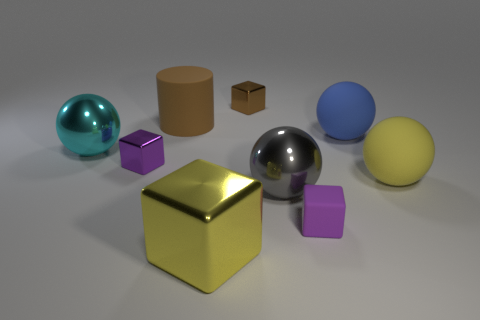There is a sphere that is the same color as the big shiny cube; what size is it?
Provide a succinct answer. Large. What number of other objects are there of the same shape as the blue rubber thing?
Ensure brevity in your answer.  3. Is the shape of the yellow thing that is right of the big shiny cube the same as  the cyan metal thing?
Provide a succinct answer. Yes. What color is the matte object in front of the big gray object?
Provide a succinct answer. Purple. There is a brown thing that is the same material as the yellow cube; what shape is it?
Your answer should be compact. Cube. Is there any other thing that has the same color as the big cylinder?
Your answer should be very brief. Yes. Are there more rubber cubes right of the blue thing than large cyan metal objects that are behind the brown rubber cylinder?
Your answer should be compact. No. What number of purple balls are the same size as the cyan object?
Offer a terse response. 0. Are there fewer big shiny objects that are to the right of the big gray ball than big brown matte objects to the right of the yellow metal object?
Offer a terse response. No. Are there any large gray metallic things of the same shape as the large blue rubber object?
Provide a short and direct response. Yes. 